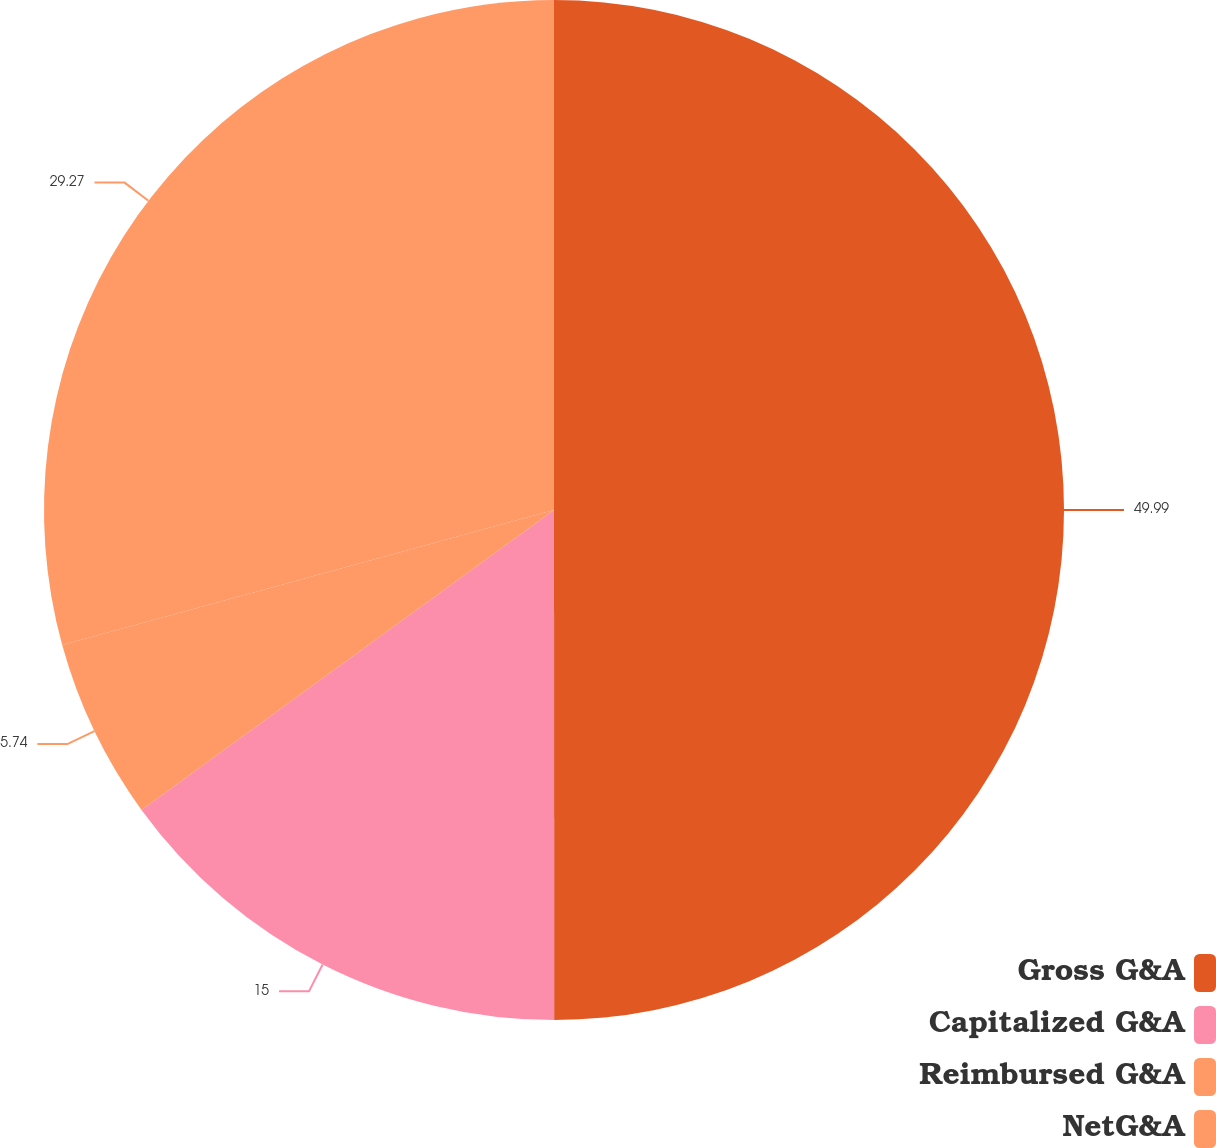Convert chart to OTSL. <chart><loc_0><loc_0><loc_500><loc_500><pie_chart><fcel>Gross G&A<fcel>Capitalized G&A<fcel>Reimbursed G&A<fcel>NetG&A<nl><fcel>50.0%<fcel>15.0%<fcel>5.74%<fcel>29.27%<nl></chart> 